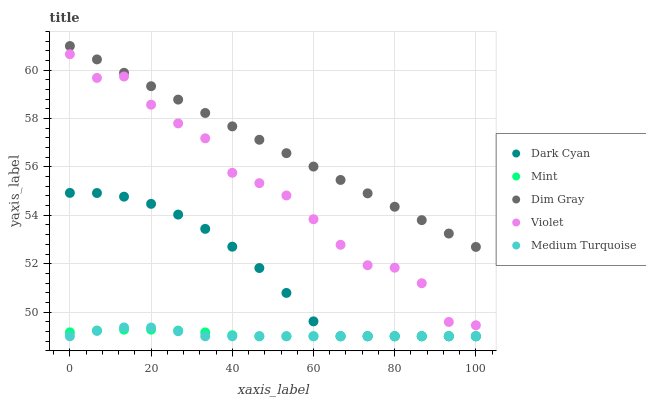Does Medium Turquoise have the minimum area under the curve?
Answer yes or no. Yes. Does Dim Gray have the maximum area under the curve?
Answer yes or no. Yes. Does Mint have the minimum area under the curve?
Answer yes or no. No. Does Mint have the maximum area under the curve?
Answer yes or no. No. Is Dim Gray the smoothest?
Answer yes or no. Yes. Is Violet the roughest?
Answer yes or no. Yes. Is Mint the smoothest?
Answer yes or no. No. Is Mint the roughest?
Answer yes or no. No. Does Dark Cyan have the lowest value?
Answer yes or no. Yes. Does Dim Gray have the lowest value?
Answer yes or no. No. Does Dim Gray have the highest value?
Answer yes or no. Yes. Does Mint have the highest value?
Answer yes or no. No. Is Medium Turquoise less than Violet?
Answer yes or no. Yes. Is Dim Gray greater than Dark Cyan?
Answer yes or no. Yes. Does Dark Cyan intersect Mint?
Answer yes or no. Yes. Is Dark Cyan less than Mint?
Answer yes or no. No. Is Dark Cyan greater than Mint?
Answer yes or no. No. Does Medium Turquoise intersect Violet?
Answer yes or no. No. 